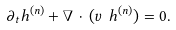<formula> <loc_0><loc_0><loc_500><loc_500>\partial _ { t } h ^ { ( n ) } + \nabla \, \cdot \, ( { v } \ h ^ { ( n ) } ) = 0 .</formula> 